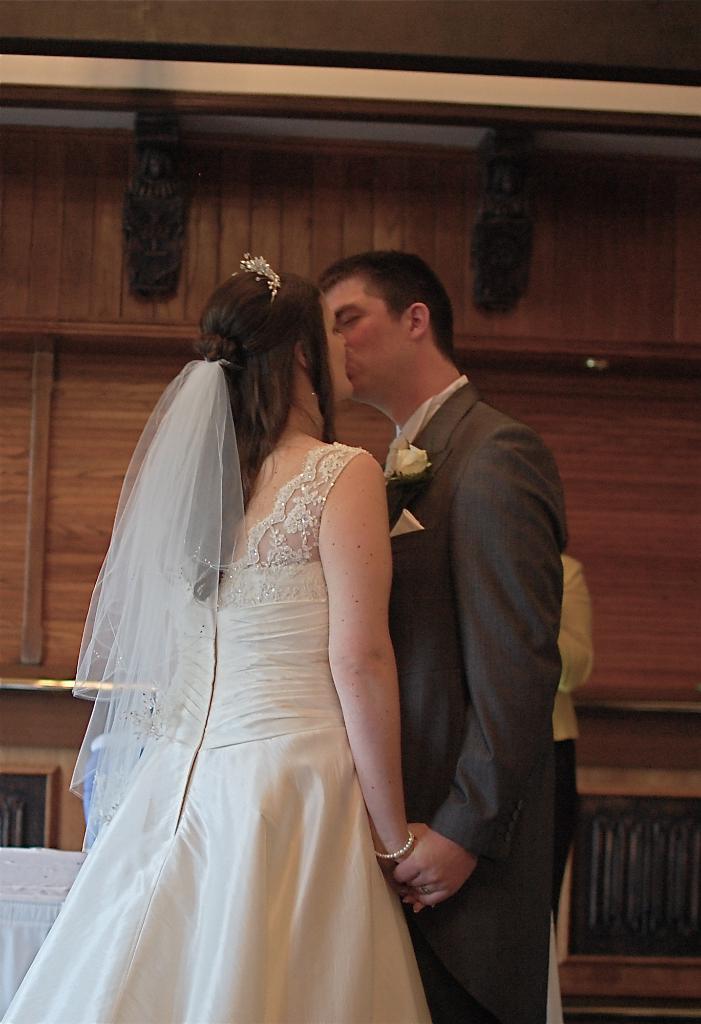In one or two sentences, can you explain what this image depicts? There is a man and a woman. Woman is wearing a crown and a veil. Man is having a flower on the coat. In the back there is a wooden wall. 